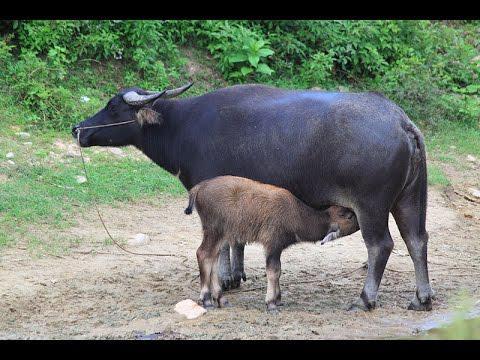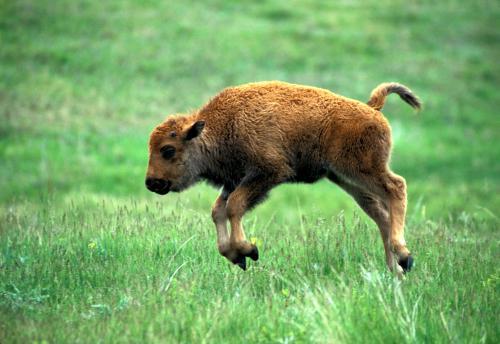The first image is the image on the left, the second image is the image on the right. Considering the images on both sides, is "A calf is being fed by it's mother" valid? Answer yes or no. Yes. 